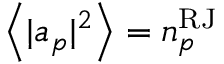Convert formula to latex. <formula><loc_0><loc_0><loc_500><loc_500>\left < | a _ { p } | ^ { 2 } \right > = n _ { p } ^ { R J }</formula> 